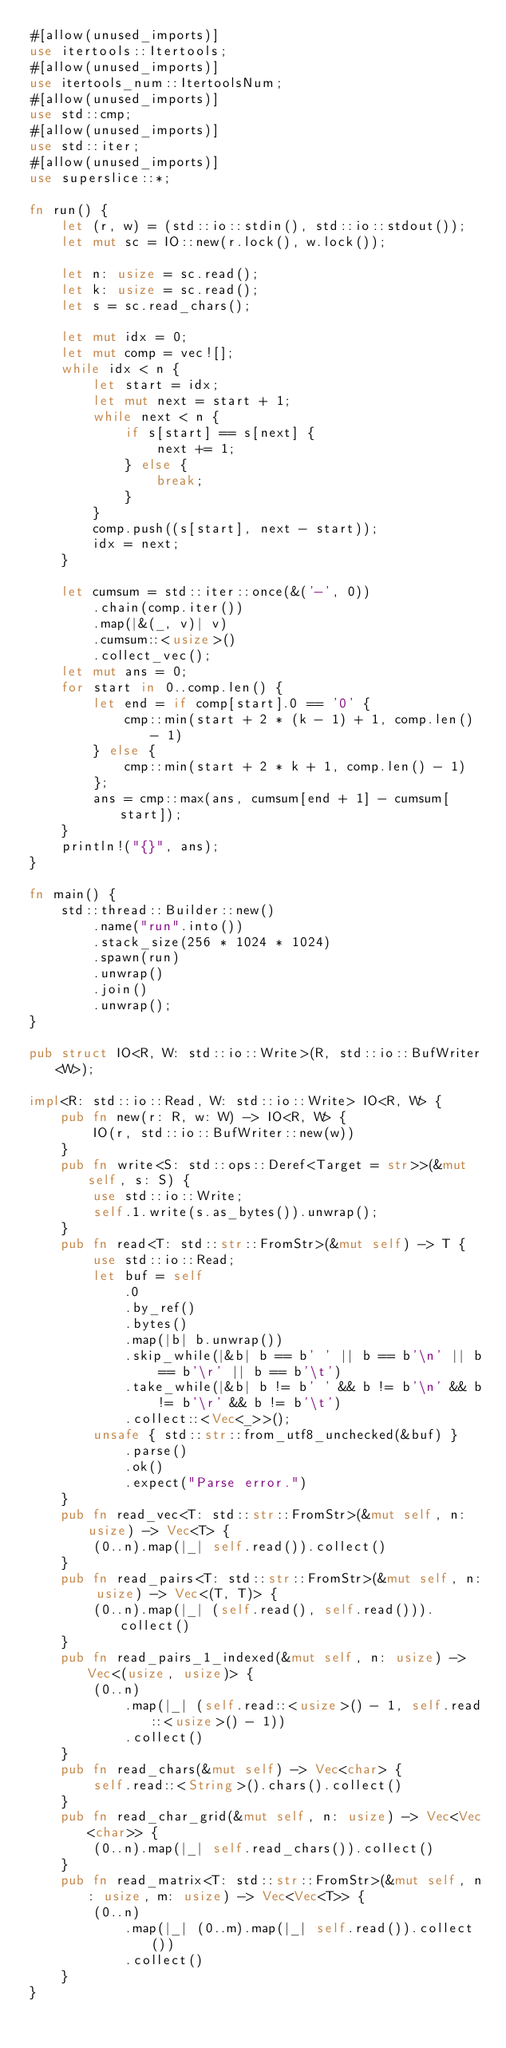<code> <loc_0><loc_0><loc_500><loc_500><_Rust_>#[allow(unused_imports)]
use itertools::Itertools;
#[allow(unused_imports)]
use itertools_num::ItertoolsNum;
#[allow(unused_imports)]
use std::cmp;
#[allow(unused_imports)]
use std::iter;
#[allow(unused_imports)]
use superslice::*;

fn run() {
    let (r, w) = (std::io::stdin(), std::io::stdout());
    let mut sc = IO::new(r.lock(), w.lock());

    let n: usize = sc.read();
    let k: usize = sc.read();
    let s = sc.read_chars();

    let mut idx = 0;
    let mut comp = vec![];
    while idx < n {
        let start = idx;
        let mut next = start + 1;
        while next < n {
            if s[start] == s[next] {
                next += 1;
            } else {
                break;
            }
        }
        comp.push((s[start], next - start));
        idx = next;
    }

    let cumsum = std::iter::once(&('-', 0))
        .chain(comp.iter())
        .map(|&(_, v)| v)
        .cumsum::<usize>()
        .collect_vec();
    let mut ans = 0;
    for start in 0..comp.len() {
        let end = if comp[start].0 == '0' {
            cmp::min(start + 2 * (k - 1) + 1, comp.len() - 1)
        } else {
            cmp::min(start + 2 * k + 1, comp.len() - 1)
        };
        ans = cmp::max(ans, cumsum[end + 1] - cumsum[start]);
    }
    println!("{}", ans);
}

fn main() {
    std::thread::Builder::new()
        .name("run".into())
        .stack_size(256 * 1024 * 1024)
        .spawn(run)
        .unwrap()
        .join()
        .unwrap();
}

pub struct IO<R, W: std::io::Write>(R, std::io::BufWriter<W>);

impl<R: std::io::Read, W: std::io::Write> IO<R, W> {
    pub fn new(r: R, w: W) -> IO<R, W> {
        IO(r, std::io::BufWriter::new(w))
    }
    pub fn write<S: std::ops::Deref<Target = str>>(&mut self, s: S) {
        use std::io::Write;
        self.1.write(s.as_bytes()).unwrap();
    }
    pub fn read<T: std::str::FromStr>(&mut self) -> T {
        use std::io::Read;
        let buf = self
            .0
            .by_ref()
            .bytes()
            .map(|b| b.unwrap())
            .skip_while(|&b| b == b' ' || b == b'\n' || b == b'\r' || b == b'\t')
            .take_while(|&b| b != b' ' && b != b'\n' && b != b'\r' && b != b'\t')
            .collect::<Vec<_>>();
        unsafe { std::str::from_utf8_unchecked(&buf) }
            .parse()
            .ok()
            .expect("Parse error.")
    }
    pub fn read_vec<T: std::str::FromStr>(&mut self, n: usize) -> Vec<T> {
        (0..n).map(|_| self.read()).collect()
    }
    pub fn read_pairs<T: std::str::FromStr>(&mut self, n: usize) -> Vec<(T, T)> {
        (0..n).map(|_| (self.read(), self.read())).collect()
    }
    pub fn read_pairs_1_indexed(&mut self, n: usize) -> Vec<(usize, usize)> {
        (0..n)
            .map(|_| (self.read::<usize>() - 1, self.read::<usize>() - 1))
            .collect()
    }
    pub fn read_chars(&mut self) -> Vec<char> {
        self.read::<String>().chars().collect()
    }
    pub fn read_char_grid(&mut self, n: usize) -> Vec<Vec<char>> {
        (0..n).map(|_| self.read_chars()).collect()
    }
    pub fn read_matrix<T: std::str::FromStr>(&mut self, n: usize, m: usize) -> Vec<Vec<T>> {
        (0..n)
            .map(|_| (0..m).map(|_| self.read()).collect())
            .collect()
    }
}
</code> 